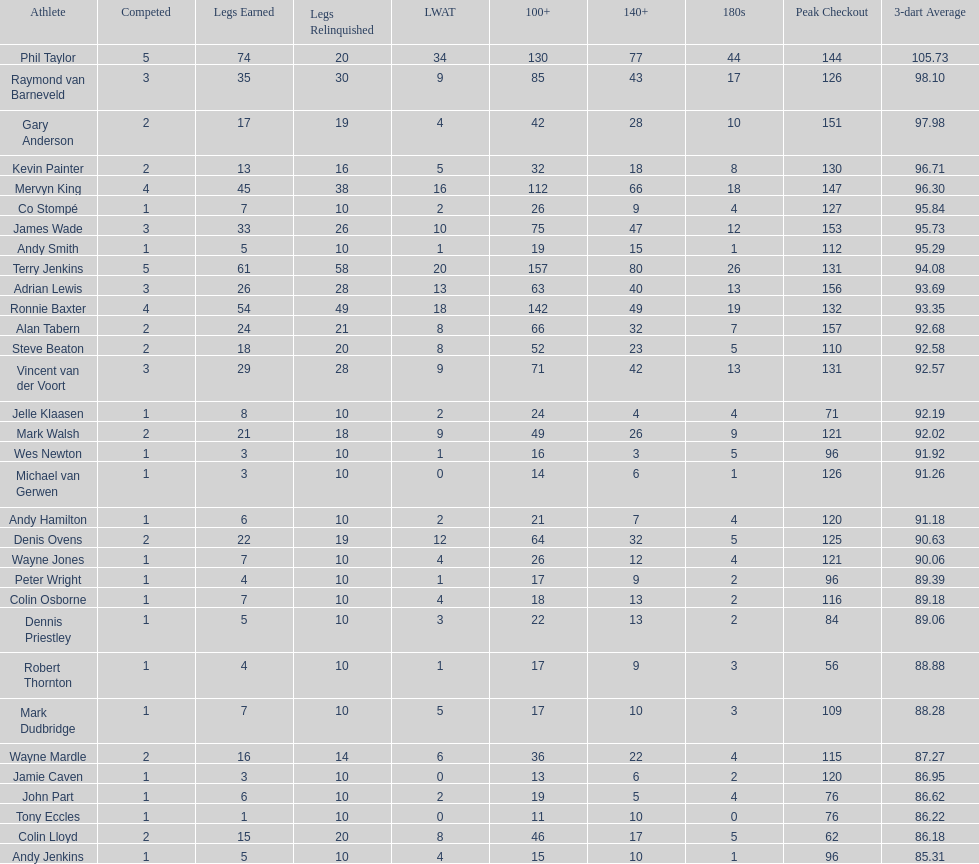How many players have a 3 dart average of more than 97? 3. 